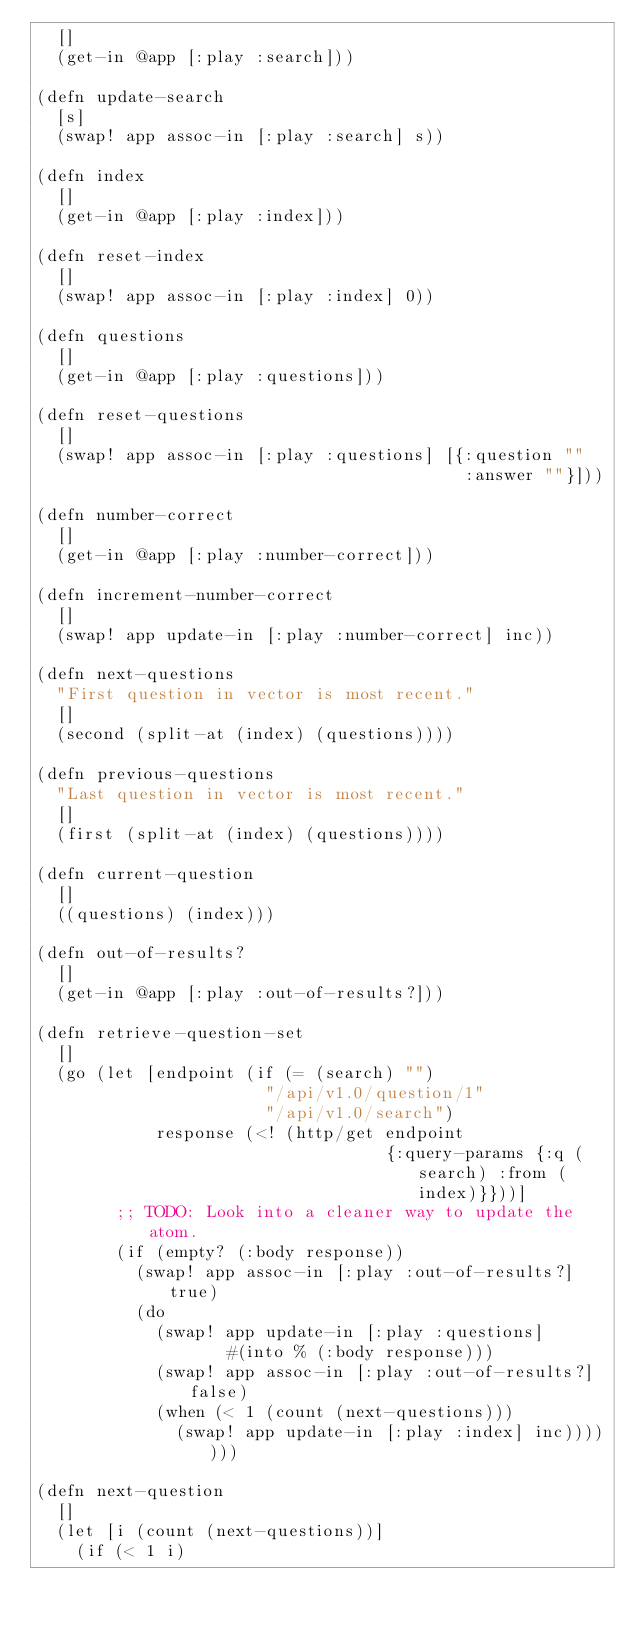<code> <loc_0><loc_0><loc_500><loc_500><_Clojure_>  []
  (get-in @app [:play :search]))

(defn update-search
  [s]
  (swap! app assoc-in [:play :search] s))

(defn index
  []
  (get-in @app [:play :index]))

(defn reset-index
  []
  (swap! app assoc-in [:play :index] 0))

(defn questions
  []
  (get-in @app [:play :questions]))

(defn reset-questions
  []
  (swap! app assoc-in [:play :questions] [{:question ""
                                           :answer ""}]))

(defn number-correct
  []
  (get-in @app [:play :number-correct]))

(defn increment-number-correct
  []
  (swap! app update-in [:play :number-correct] inc))

(defn next-questions
  "First question in vector is most recent."
  []
  (second (split-at (index) (questions))))

(defn previous-questions
  "Last question in vector is most recent."
  []
  (first (split-at (index) (questions))))

(defn current-question
  []
  ((questions) (index)))

(defn out-of-results?
  []
  (get-in @app [:play :out-of-results?]))

(defn retrieve-question-set
  []
  (go (let [endpoint (if (= (search) "")
                       "/api/v1.0/question/1"
                       "/api/v1.0/search")
            response (<! (http/get endpoint
                                   {:query-params {:q (search) :from (index)}}))]
        ;; TODO: Look into a cleaner way to update the atom.
        (if (empty? (:body response))
          (swap! app assoc-in [:play :out-of-results?] true)
          (do
            (swap! app update-in [:play :questions]
                   #(into % (:body response)))
            (swap! app assoc-in [:play :out-of-results?] false)
            (when (< 1 (count (next-questions)))
              (swap! app update-in [:play :index] inc)))))))

(defn next-question
  []
  (let [i (count (next-questions))]
    (if (< 1 i)</code> 